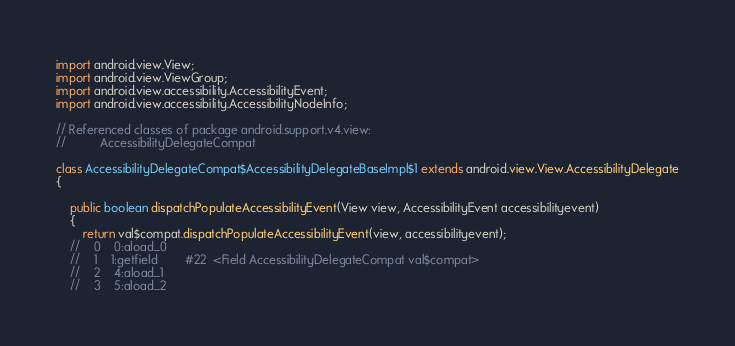<code> <loc_0><loc_0><loc_500><loc_500><_Java_>import android.view.View;
import android.view.ViewGroup;
import android.view.accessibility.AccessibilityEvent;
import android.view.accessibility.AccessibilityNodeInfo;

// Referenced classes of package android.support.v4.view:
//			AccessibilityDelegateCompat

class AccessibilityDelegateCompat$AccessibilityDelegateBaseImpl$1 extends android.view.View.AccessibilityDelegate
{

	public boolean dispatchPopulateAccessibilityEvent(View view, AccessibilityEvent accessibilityevent)
	{
		return val$compat.dispatchPopulateAccessibilityEvent(view, accessibilityevent);
	//    0    0:aload_0         
	//    1    1:getfield        #22  <Field AccessibilityDelegateCompat val$compat>
	//    2    4:aload_1         
	//    3    5:aload_2         </code> 